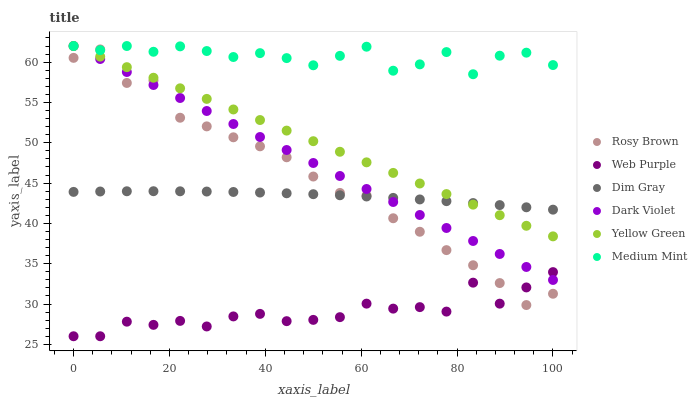Does Web Purple have the minimum area under the curve?
Answer yes or no. Yes. Does Medium Mint have the maximum area under the curve?
Answer yes or no. Yes. Does Dim Gray have the minimum area under the curve?
Answer yes or no. No. Does Dim Gray have the maximum area under the curve?
Answer yes or no. No. Is Dark Violet the smoothest?
Answer yes or no. Yes. Is Web Purple the roughest?
Answer yes or no. Yes. Is Dim Gray the smoothest?
Answer yes or no. No. Is Dim Gray the roughest?
Answer yes or no. No. Does Web Purple have the lowest value?
Answer yes or no. Yes. Does Dim Gray have the lowest value?
Answer yes or no. No. Does Dark Violet have the highest value?
Answer yes or no. Yes. Does Dim Gray have the highest value?
Answer yes or no. No. Is Web Purple less than Dim Gray?
Answer yes or no. Yes. Is Medium Mint greater than Web Purple?
Answer yes or no. Yes. Does Web Purple intersect Dark Violet?
Answer yes or no. Yes. Is Web Purple less than Dark Violet?
Answer yes or no. No. Is Web Purple greater than Dark Violet?
Answer yes or no. No. Does Web Purple intersect Dim Gray?
Answer yes or no. No. 